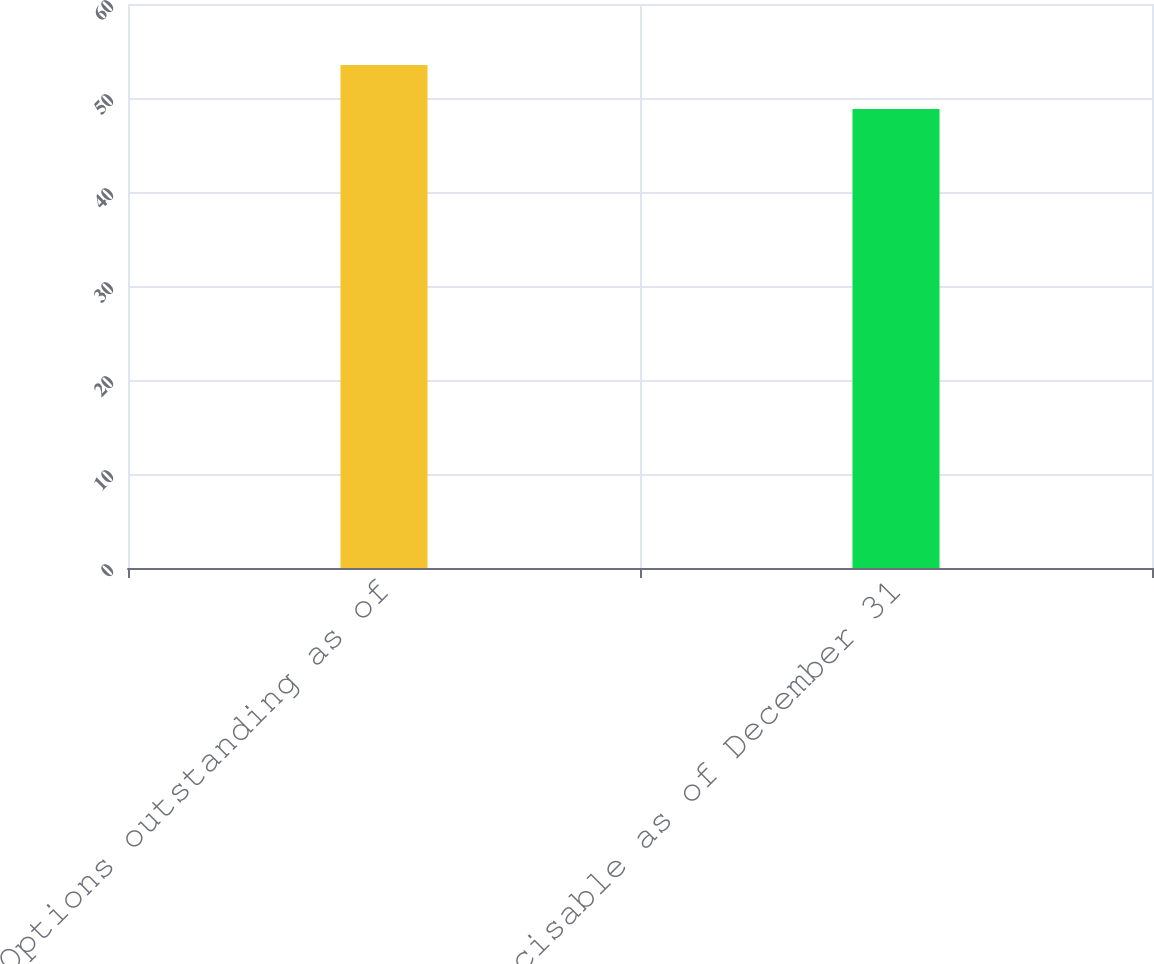<chart> <loc_0><loc_0><loc_500><loc_500><bar_chart><fcel>Options outstanding as of<fcel>Exercisable as of December 31<nl><fcel>53.51<fcel>48.83<nl></chart> 